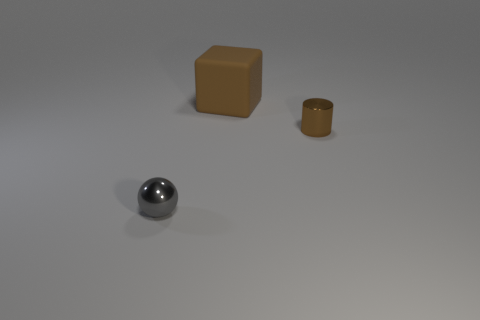How would you imagine interacting with these objects in a real-world scenario? In a real-world setting, one might use the brown cylindrical container to store small items or as a decorative piece, while the orange cube could serve as a simplistic toy, paperweight, or even a seat, depending on its size and material. The gray sphere's reflective quality suggests it could be a decorative element or part of a game like boules. 